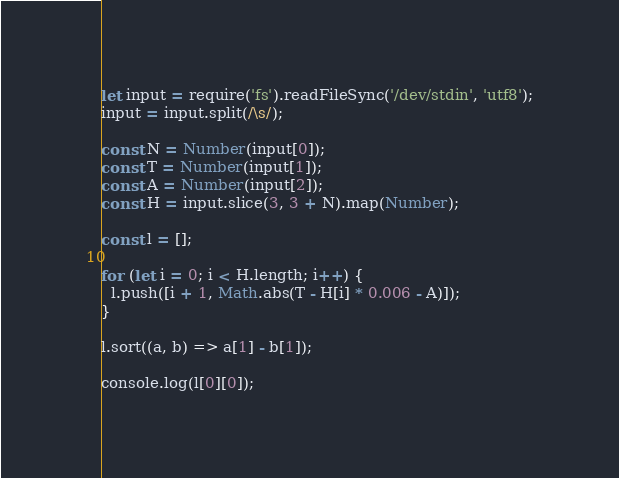Convert code to text. <code><loc_0><loc_0><loc_500><loc_500><_TypeScript_>let input = require('fs').readFileSync('/dev/stdin', 'utf8');
input = input.split(/\s/);

const N = Number(input[0]);
const T = Number(input[1]);
const A = Number(input[2]);
const H = input.slice(3, 3 + N).map(Number);

const l = [];

for (let i = 0; i < H.length; i++) {
  l.push([i + 1, Math.abs(T - H[i] * 0.006 - A)]);
}

l.sort((a, b) => a[1] - b[1]);

console.log(l[0][0]);
</code> 